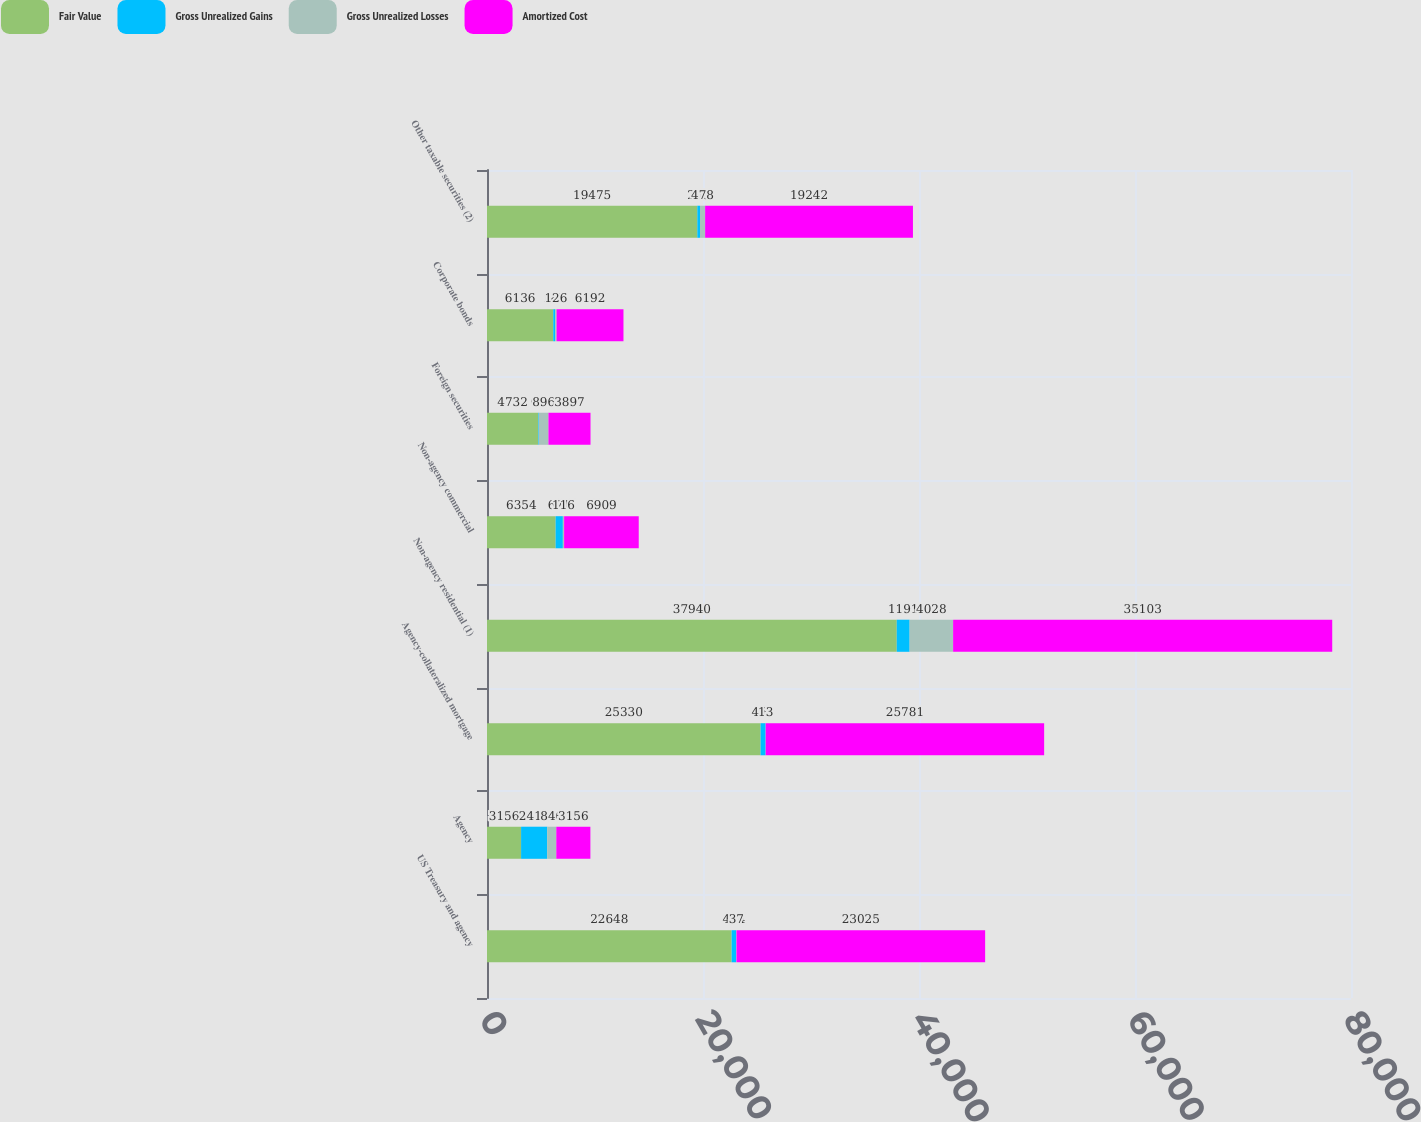Convert chart to OTSL. <chart><loc_0><loc_0><loc_500><loc_500><stacked_bar_chart><ecel><fcel>US Treasury and agency<fcel>Agency<fcel>Agency-collateralized mortgage<fcel>Non-agency residential (1)<fcel>Non-agency commercial<fcel>Foreign securities<fcel>Corporate bonds<fcel>Other taxable securities (2)<nl><fcel>Fair Value<fcel>22648<fcel>3156<fcel>25330<fcel>37940<fcel>6354<fcel>4732<fcel>6136<fcel>19475<nl><fcel>Gross Unrealized Gains<fcel>414<fcel>2415<fcel>464<fcel>1191<fcel>671<fcel>61<fcel>182<fcel>245<nl><fcel>Gross Unrealized Losses<fcel>37<fcel>846<fcel>13<fcel>4028<fcel>116<fcel>896<fcel>126<fcel>478<nl><fcel>Amortized Cost<fcel>23025<fcel>3156<fcel>25781<fcel>35103<fcel>6909<fcel>3897<fcel>6192<fcel>19242<nl></chart> 